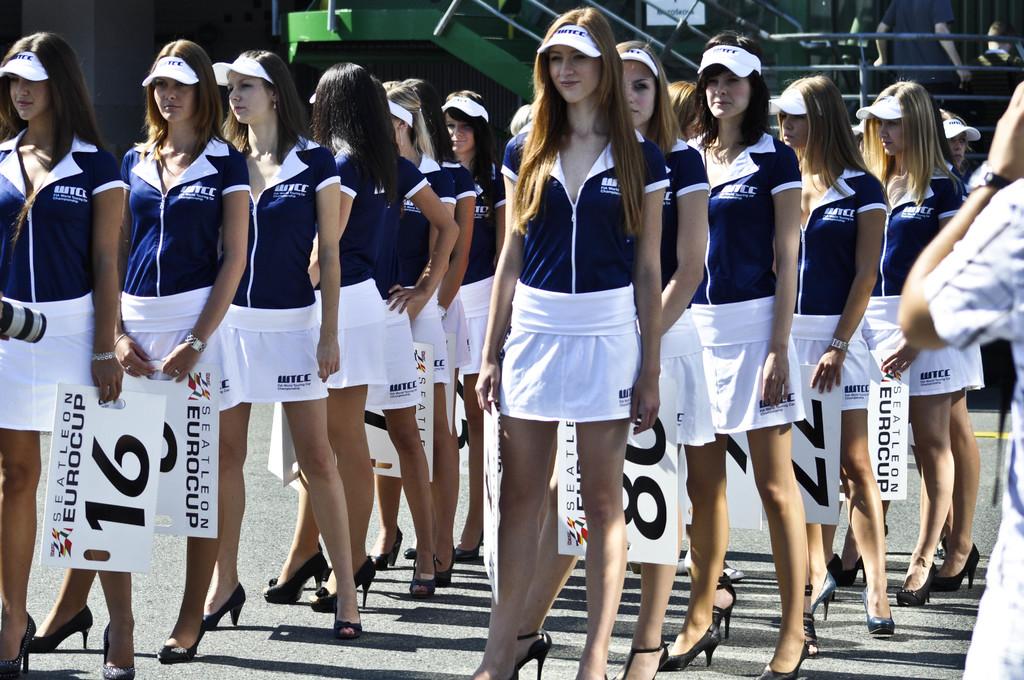What event are these women at?
Ensure brevity in your answer.  Eurocup. What number is on the sign of the woman at the far left?
Your answer should be very brief. 16. 